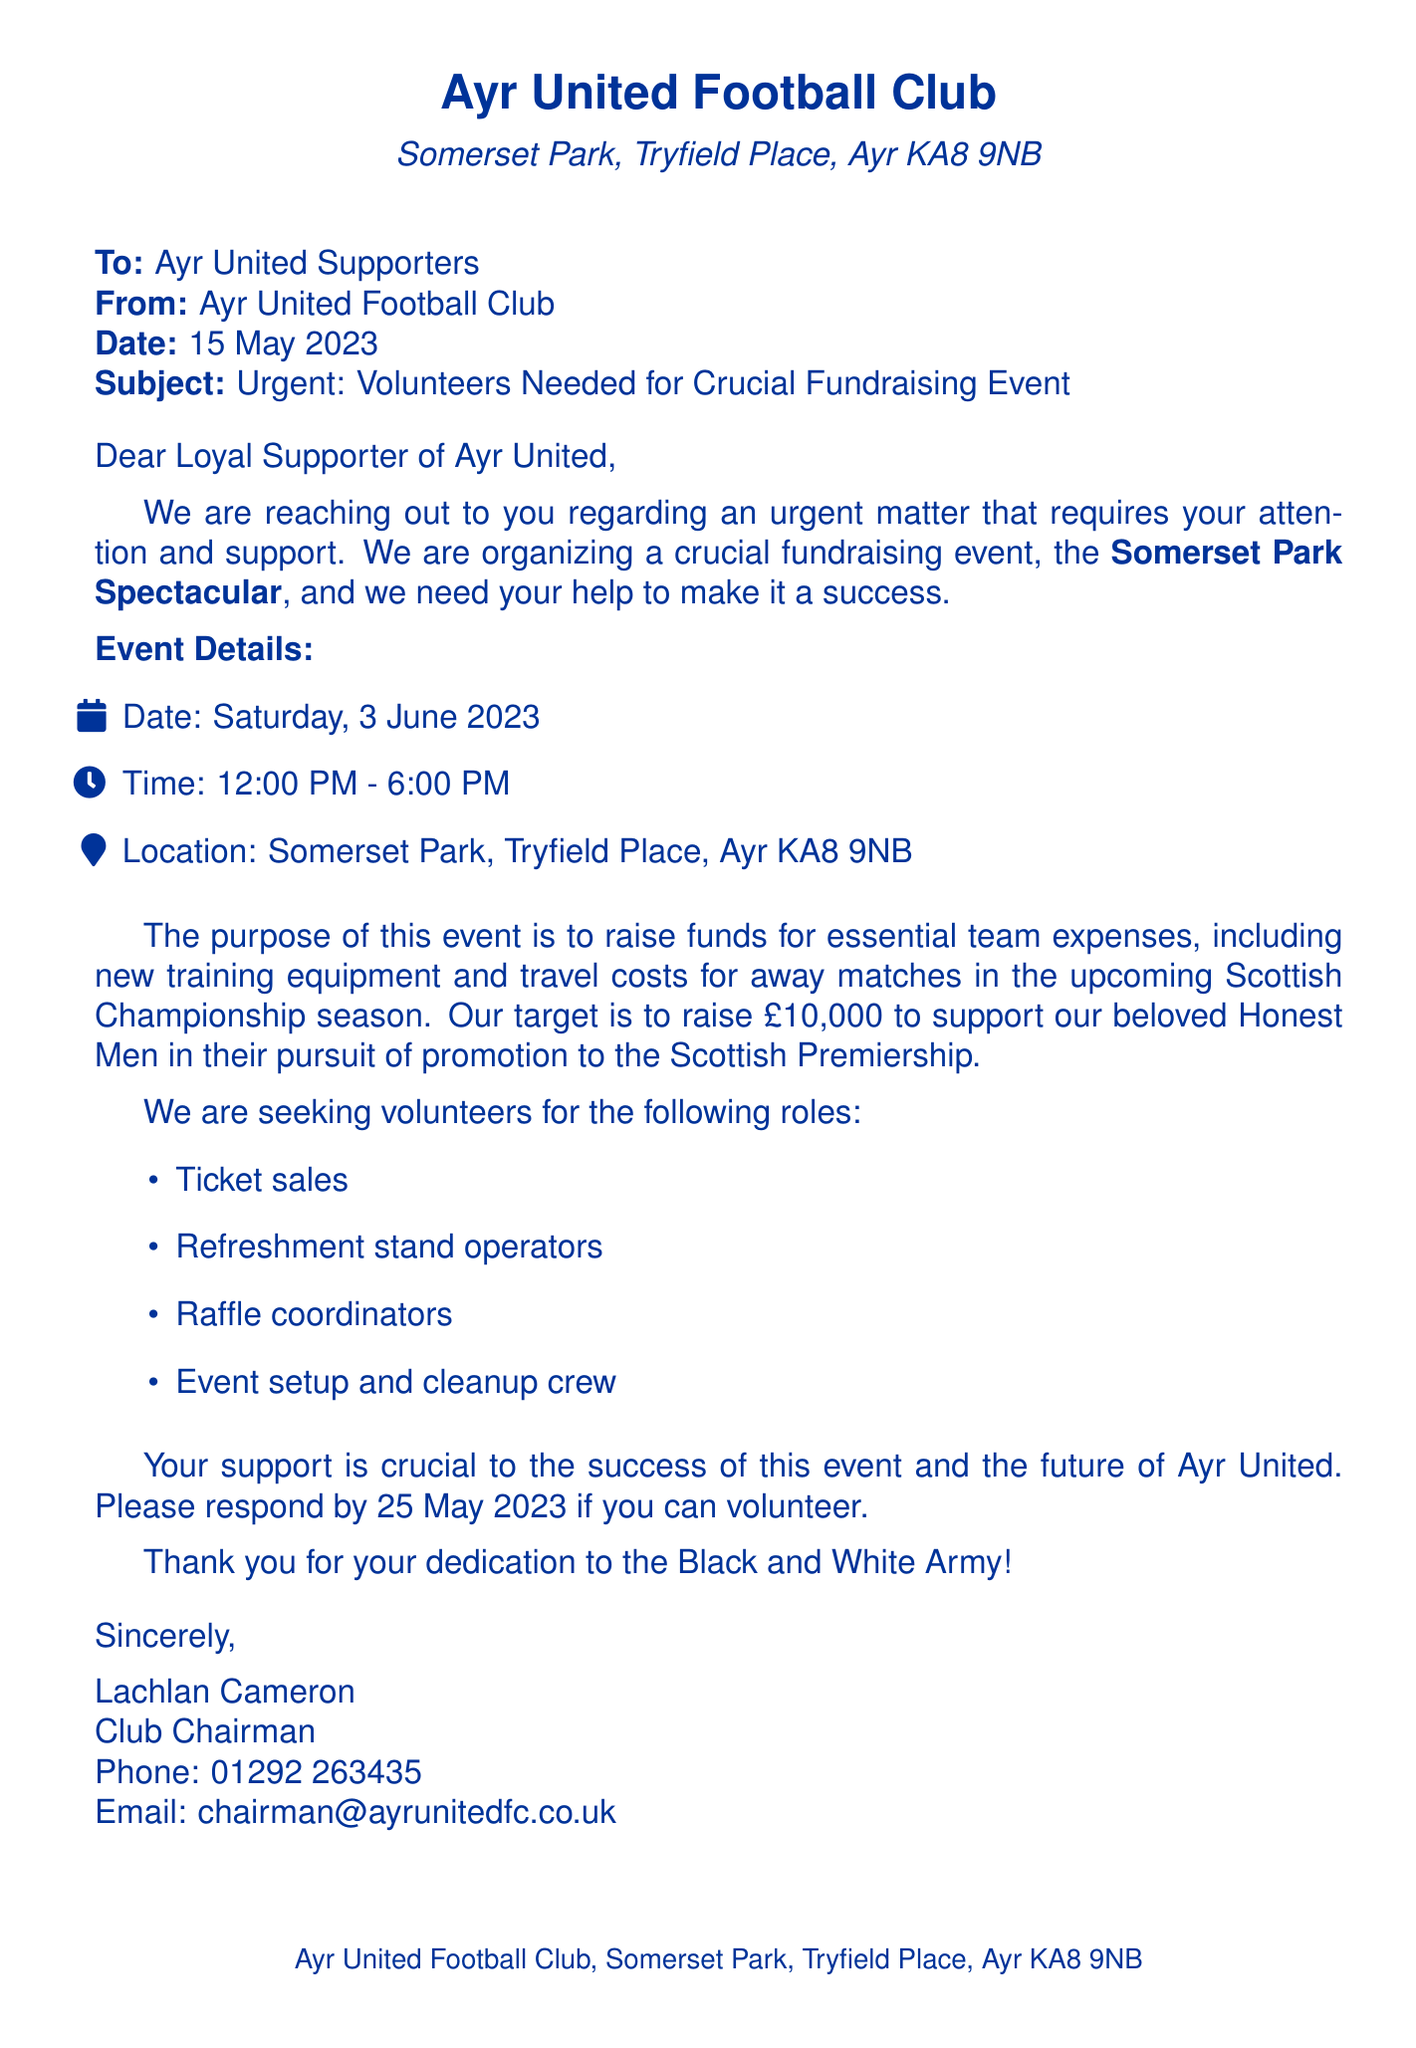What is the date of the fundraising event? The date of the event is specified in the document as 3 June 2023.
Answer: 3 June 2023 What is the location of Somerset Park? The address of Somerset Park is provided in the document as Tryfield Place, Ayr KA8 9NB.
Answer: Tryfield Place, Ayr KA8 9NB What is the fundraising target amount? The document states the target amount we aim to raise is £10,000.
Answer: £10,000 Who is the sender of the fax? The document indicates that the sender is Lachlan Cameron, the Club Chairman.
Answer: Lachlan Cameron What types of volunteer roles are needed? The document lists roles such as ticket sales, refreshment stand operators, raffle coordinators, and event setup and cleanup crew.
Answer: Ticket sales, refreshment stand operators, raffle coordinators, event setup and cleanup crew By which date should volunteers respond? The document requests that volunteers respond by 25 May 2023.
Answer: 25 May 2023 What time does the fundraising event start? The start time for the event is mentioned as 12:00 PM.
Answer: 12:00 PM What purpose does the fundraiser serve? The document explains that the fundraiser is intended to support team expenses, such as new training equipment and travel costs.
Answer: Team expenses How long will the fundraising event last? The event is scheduled to last from 12:00 PM to 6:00 PM, which totals 6 hours.
Answer: 6 hours 